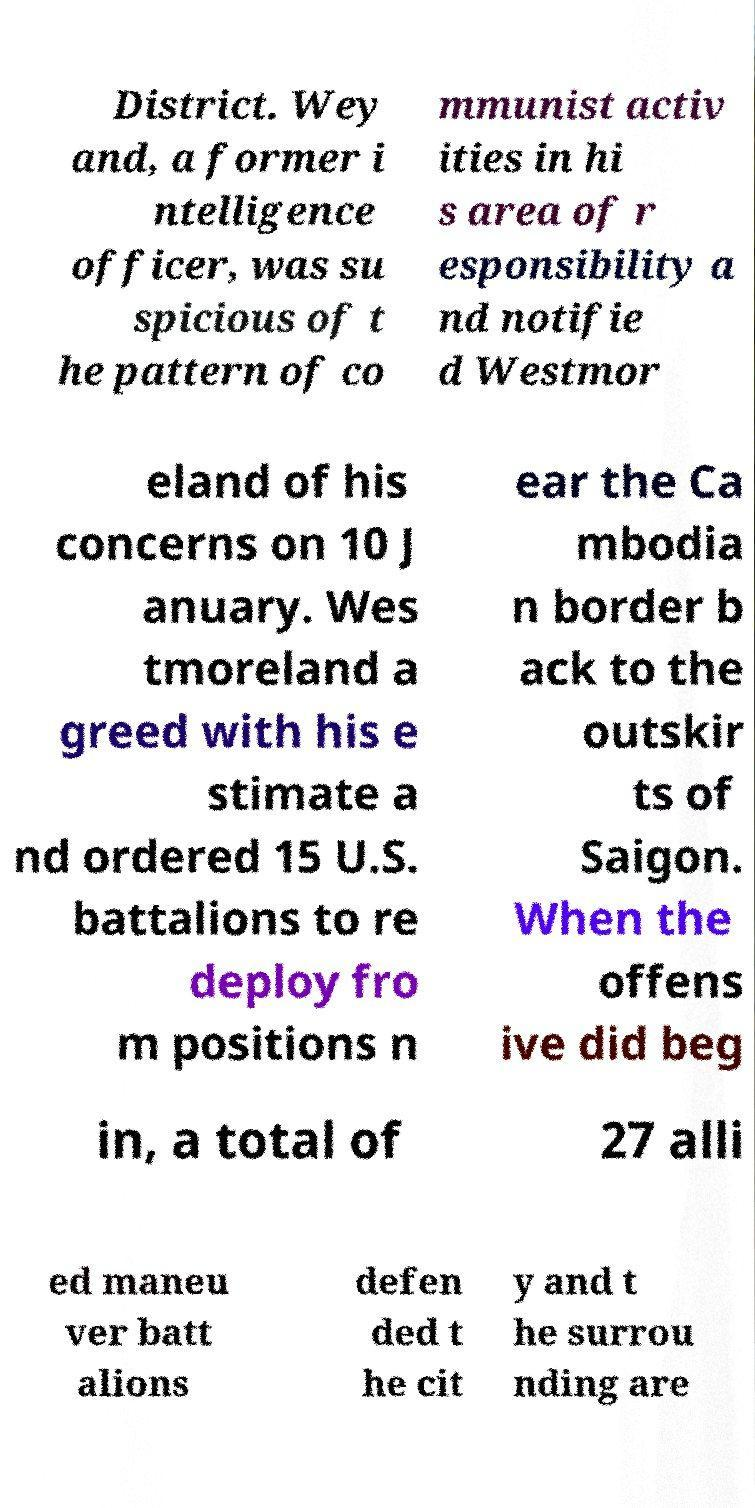Can you accurately transcribe the text from the provided image for me? District. Wey and, a former i ntelligence officer, was su spicious of t he pattern of co mmunist activ ities in hi s area of r esponsibility a nd notifie d Westmor eland of his concerns on 10 J anuary. Wes tmoreland a greed with his e stimate a nd ordered 15 U.S. battalions to re deploy fro m positions n ear the Ca mbodia n border b ack to the outskir ts of Saigon. When the offens ive did beg in, a total of 27 alli ed maneu ver batt alions defen ded t he cit y and t he surrou nding are 